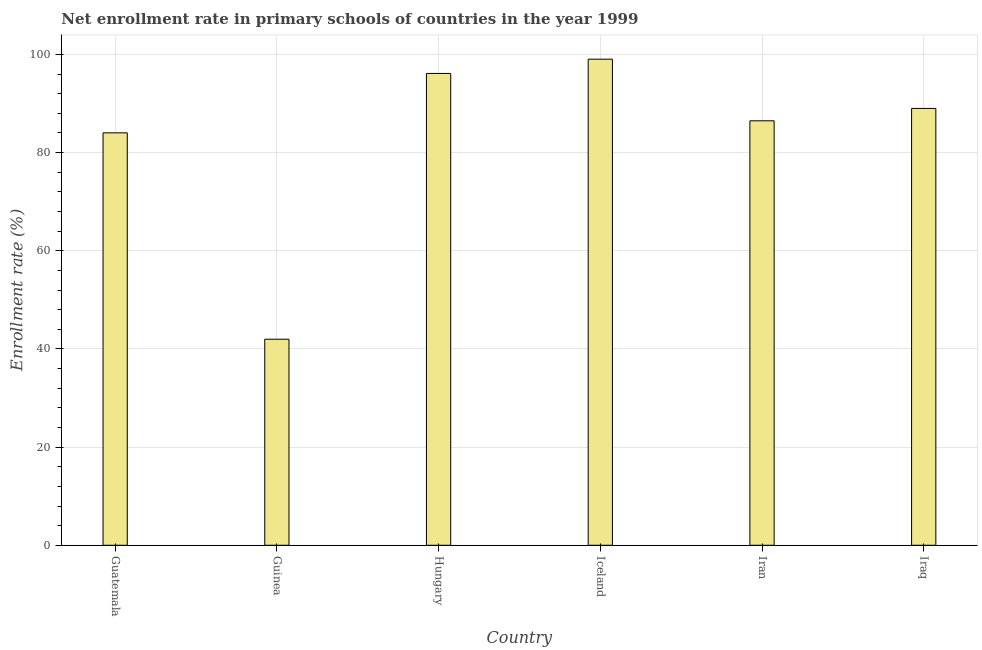Does the graph contain any zero values?
Your answer should be compact. No. What is the title of the graph?
Provide a succinct answer. Net enrollment rate in primary schools of countries in the year 1999. What is the label or title of the X-axis?
Offer a terse response. Country. What is the label or title of the Y-axis?
Offer a terse response. Enrollment rate (%). What is the net enrollment rate in primary schools in Iraq?
Your answer should be compact. 89. Across all countries, what is the maximum net enrollment rate in primary schools?
Your answer should be very brief. 99.03. Across all countries, what is the minimum net enrollment rate in primary schools?
Offer a terse response. 41.98. In which country was the net enrollment rate in primary schools minimum?
Your response must be concise. Guinea. What is the sum of the net enrollment rate in primary schools?
Offer a very short reply. 496.65. What is the difference between the net enrollment rate in primary schools in Hungary and Iraq?
Provide a short and direct response. 7.12. What is the average net enrollment rate in primary schools per country?
Ensure brevity in your answer.  82.78. What is the median net enrollment rate in primary schools?
Offer a terse response. 87.74. In how many countries, is the net enrollment rate in primary schools greater than 28 %?
Ensure brevity in your answer.  6. What is the difference between the highest and the second highest net enrollment rate in primary schools?
Your answer should be compact. 2.91. What is the difference between the highest and the lowest net enrollment rate in primary schools?
Provide a short and direct response. 57.05. How many countries are there in the graph?
Keep it short and to the point. 6. What is the difference between two consecutive major ticks on the Y-axis?
Your answer should be compact. 20. Are the values on the major ticks of Y-axis written in scientific E-notation?
Provide a succinct answer. No. What is the Enrollment rate (%) of Guatemala?
Offer a very short reply. 84.03. What is the Enrollment rate (%) of Guinea?
Keep it short and to the point. 41.98. What is the Enrollment rate (%) in Hungary?
Ensure brevity in your answer.  96.13. What is the Enrollment rate (%) in Iceland?
Provide a succinct answer. 99.03. What is the Enrollment rate (%) of Iran?
Your response must be concise. 86.48. What is the Enrollment rate (%) of Iraq?
Keep it short and to the point. 89. What is the difference between the Enrollment rate (%) in Guatemala and Guinea?
Give a very brief answer. 42.04. What is the difference between the Enrollment rate (%) in Guatemala and Hungary?
Your answer should be compact. -12.1. What is the difference between the Enrollment rate (%) in Guatemala and Iceland?
Your answer should be very brief. -15.01. What is the difference between the Enrollment rate (%) in Guatemala and Iran?
Offer a terse response. -2.45. What is the difference between the Enrollment rate (%) in Guatemala and Iraq?
Offer a terse response. -4.98. What is the difference between the Enrollment rate (%) in Guinea and Hungary?
Offer a very short reply. -54.14. What is the difference between the Enrollment rate (%) in Guinea and Iceland?
Your answer should be very brief. -57.05. What is the difference between the Enrollment rate (%) in Guinea and Iran?
Ensure brevity in your answer.  -44.49. What is the difference between the Enrollment rate (%) in Guinea and Iraq?
Offer a terse response. -47.02. What is the difference between the Enrollment rate (%) in Hungary and Iceland?
Provide a succinct answer. -2.91. What is the difference between the Enrollment rate (%) in Hungary and Iran?
Your response must be concise. 9.65. What is the difference between the Enrollment rate (%) in Hungary and Iraq?
Offer a terse response. 7.12. What is the difference between the Enrollment rate (%) in Iceland and Iran?
Make the answer very short. 12.56. What is the difference between the Enrollment rate (%) in Iceland and Iraq?
Provide a short and direct response. 10.03. What is the difference between the Enrollment rate (%) in Iran and Iraq?
Keep it short and to the point. -2.52. What is the ratio of the Enrollment rate (%) in Guatemala to that in Guinea?
Give a very brief answer. 2. What is the ratio of the Enrollment rate (%) in Guatemala to that in Hungary?
Make the answer very short. 0.87. What is the ratio of the Enrollment rate (%) in Guatemala to that in Iceland?
Provide a short and direct response. 0.85. What is the ratio of the Enrollment rate (%) in Guatemala to that in Iran?
Provide a succinct answer. 0.97. What is the ratio of the Enrollment rate (%) in Guatemala to that in Iraq?
Your answer should be compact. 0.94. What is the ratio of the Enrollment rate (%) in Guinea to that in Hungary?
Make the answer very short. 0.44. What is the ratio of the Enrollment rate (%) in Guinea to that in Iceland?
Your answer should be compact. 0.42. What is the ratio of the Enrollment rate (%) in Guinea to that in Iran?
Offer a very short reply. 0.48. What is the ratio of the Enrollment rate (%) in Guinea to that in Iraq?
Ensure brevity in your answer.  0.47. What is the ratio of the Enrollment rate (%) in Hungary to that in Iran?
Keep it short and to the point. 1.11. What is the ratio of the Enrollment rate (%) in Iceland to that in Iran?
Provide a short and direct response. 1.15. What is the ratio of the Enrollment rate (%) in Iceland to that in Iraq?
Ensure brevity in your answer.  1.11. What is the ratio of the Enrollment rate (%) in Iran to that in Iraq?
Offer a very short reply. 0.97. 